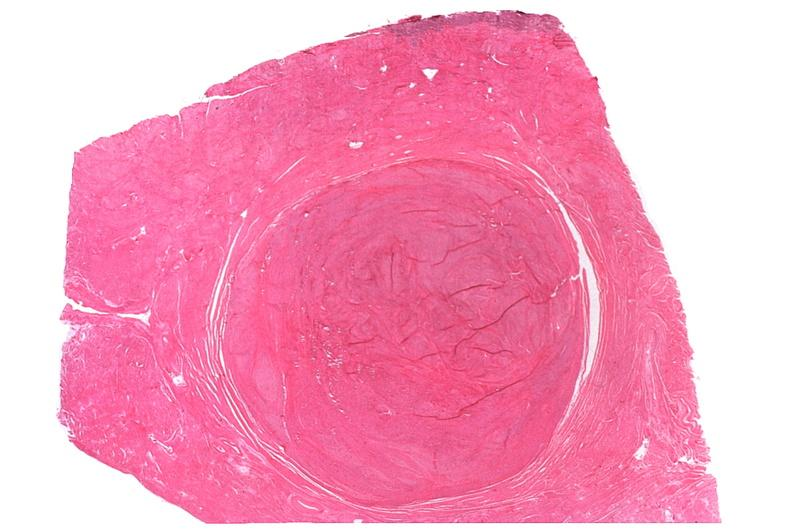what is present?
Answer the question using a single word or phrase. Female reproductive 